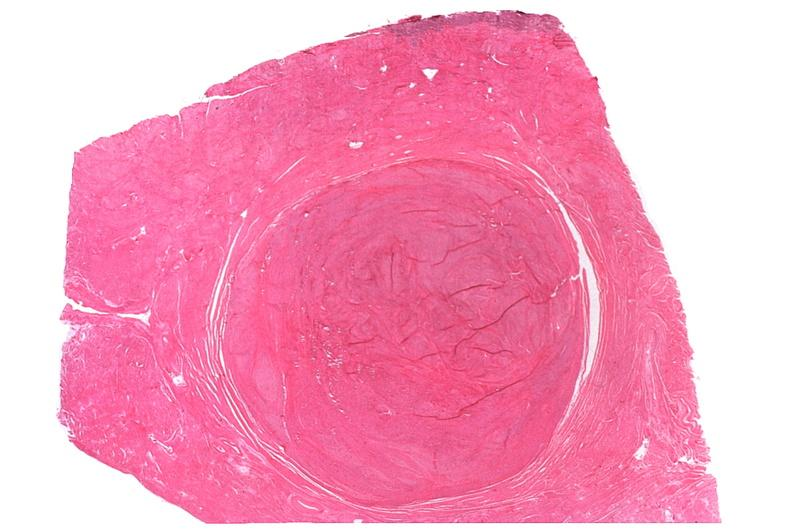what is present?
Answer the question using a single word or phrase. Female reproductive 